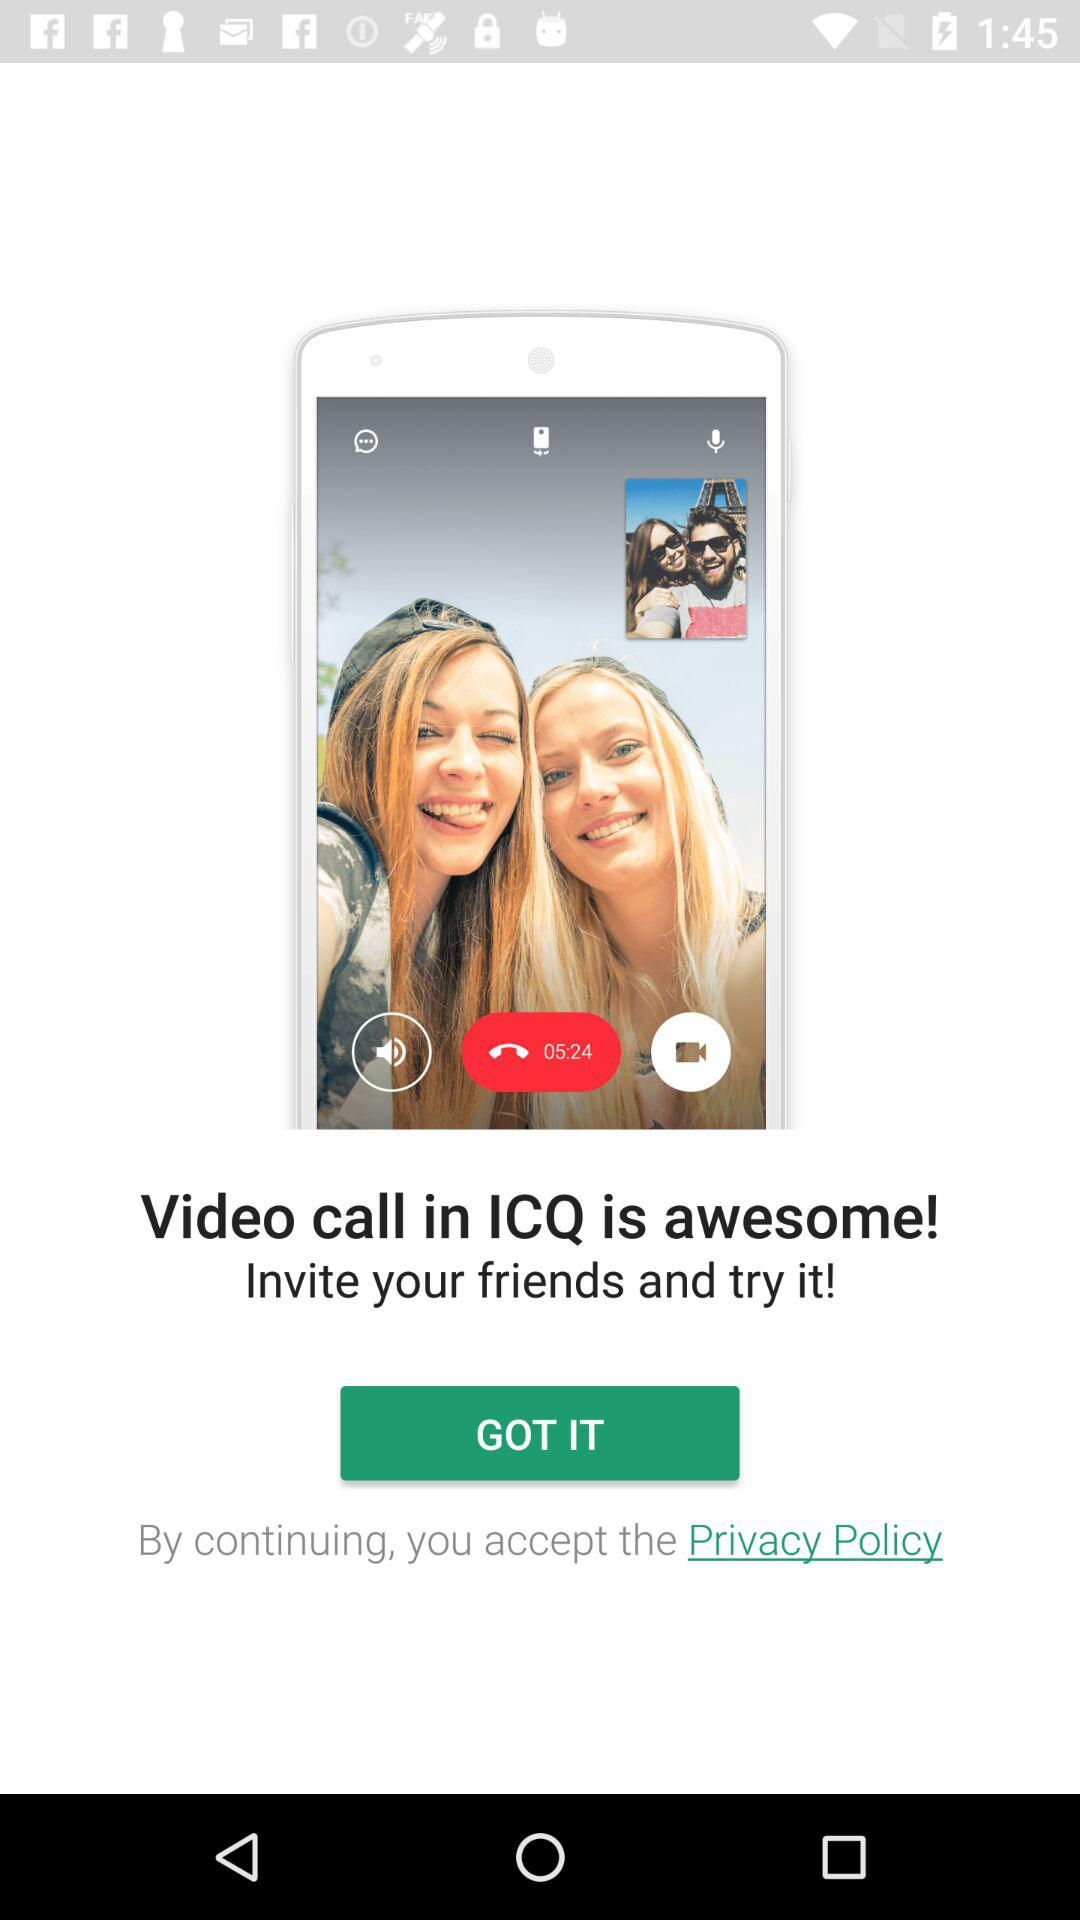What is the name of the application? The name of the application is "ICQ". 